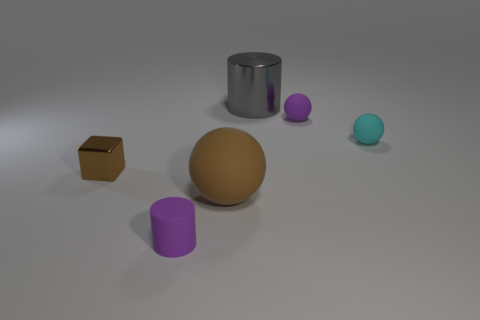Is the color of the metal object on the right side of the brown matte thing the same as the big object that is in front of the brown cube?
Your answer should be very brief. No. The matte cylinder is what color?
Offer a terse response. Purple. Is there anything else of the same color as the matte cylinder?
Your response must be concise. Yes. What is the color of the thing that is left of the brown sphere and in front of the brown metallic thing?
Your answer should be very brief. Purple. Is the size of the sphere that is on the right side of the purple matte sphere the same as the tiny shiny block?
Offer a very short reply. Yes. Are there more matte things that are behind the tiny cyan object than purple objects?
Keep it short and to the point. No. Is the cyan object the same shape as the big brown thing?
Keep it short and to the point. Yes. What size is the brown metal thing?
Make the answer very short. Small. Is the number of small purple matte cylinders behind the small brown metallic block greater than the number of big gray objects that are to the right of the shiny cylinder?
Make the answer very short. No. There is a brown metallic thing; are there any brown shiny cubes to the right of it?
Make the answer very short. No. 